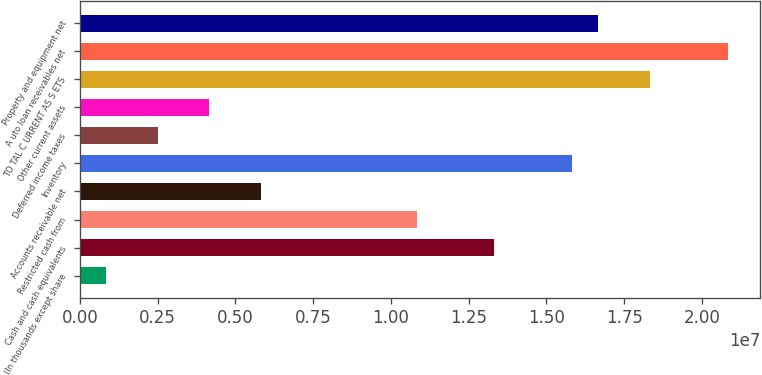Convert chart to OTSL. <chart><loc_0><loc_0><loc_500><loc_500><bar_chart><fcel>(In thousands except share<fcel>Cash and cash equivalents<fcel>Restricted cash from<fcel>Accounts receivable net<fcel>Inventory<fcel>Deferred income taxes<fcel>Other current assets<fcel>TO TAL C URRENT AS S ETS<fcel>A uto loan receivables net<fcel>Property and equipment net<nl><fcel>834003<fcel>1.33299e+07<fcel>1.08307e+07<fcel>5.83236e+06<fcel>1.58291e+07<fcel>2.50012e+06<fcel>4.16624e+06<fcel>1.83283e+07<fcel>2.08274e+07<fcel>1.66621e+07<nl></chart> 